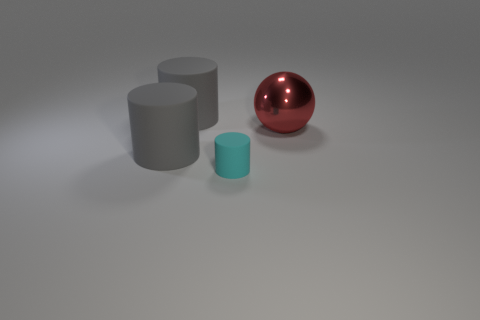What number of small matte things are behind the gray thing in front of the thing that is to the right of the cyan rubber cylinder?
Your answer should be compact. 0. What is the color of the cylinder that is behind the metal thing?
Your response must be concise. Gray. Is the color of the object on the right side of the tiny object the same as the tiny cylinder?
Give a very brief answer. No. Is there anything else that has the same size as the cyan rubber cylinder?
Keep it short and to the point. No. What material is the gray cylinder in front of the large thing to the right of the cyan object that is in front of the large red object made of?
Offer a very short reply. Rubber. Is the number of large red metal things that are in front of the red sphere greater than the number of tiny objects right of the small cyan rubber cylinder?
Your response must be concise. No. Is the cyan object the same size as the shiny sphere?
Offer a very short reply. No. What number of other big things have the same color as the large metal object?
Ensure brevity in your answer.  0. Is the number of gray rubber objects that are behind the big metal ball greater than the number of gray matte cylinders?
Offer a terse response. No. There is a ball in front of the large gray matte cylinder that is behind the metallic thing; what color is it?
Offer a very short reply. Red. 